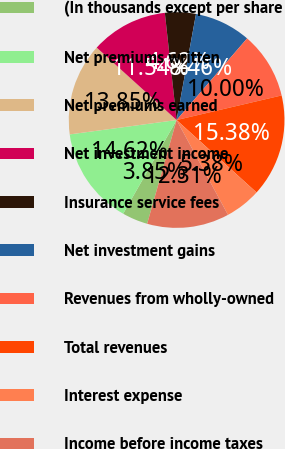<chart> <loc_0><loc_0><loc_500><loc_500><pie_chart><fcel>(In thousands except per share<fcel>Net premiums written<fcel>Net premiums earned<fcel>Net investment income<fcel>Insurance service fees<fcel>Net investment gains<fcel>Revenues from wholly-owned<fcel>Total revenues<fcel>Interest expense<fcel>Income before income taxes<nl><fcel>3.85%<fcel>14.62%<fcel>13.85%<fcel>11.54%<fcel>4.62%<fcel>8.46%<fcel>10.0%<fcel>15.38%<fcel>5.38%<fcel>12.31%<nl></chart> 